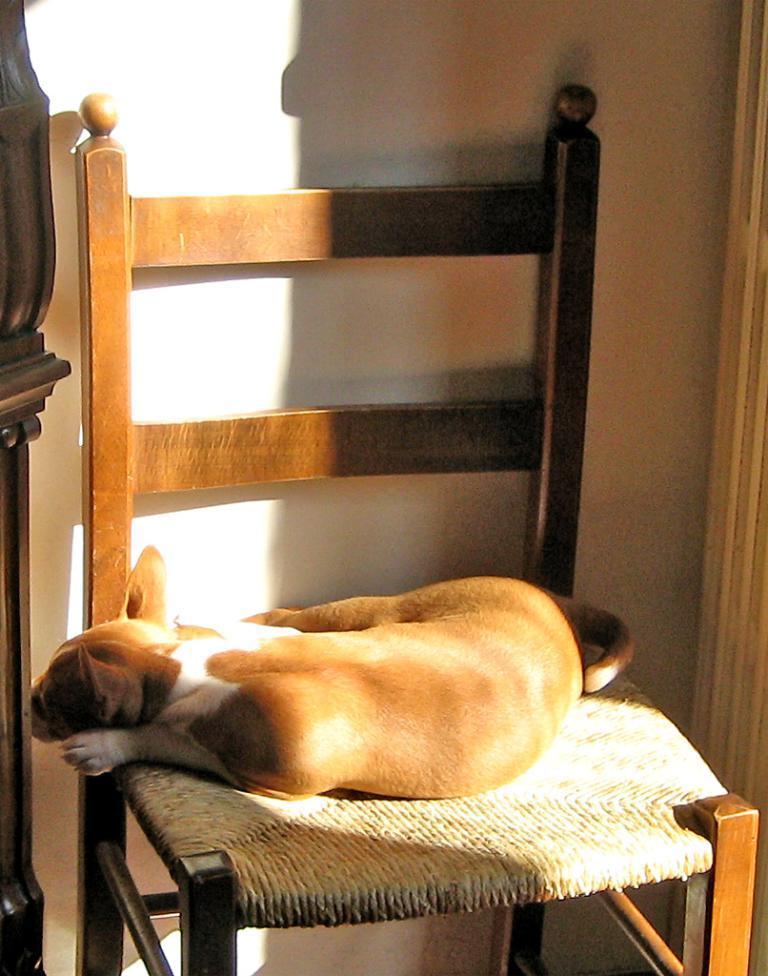Describe this image in one or two sentences. This image consists of a chair and a dog is sitting on that chair. It is in brown color. The chair is made up of wood. 